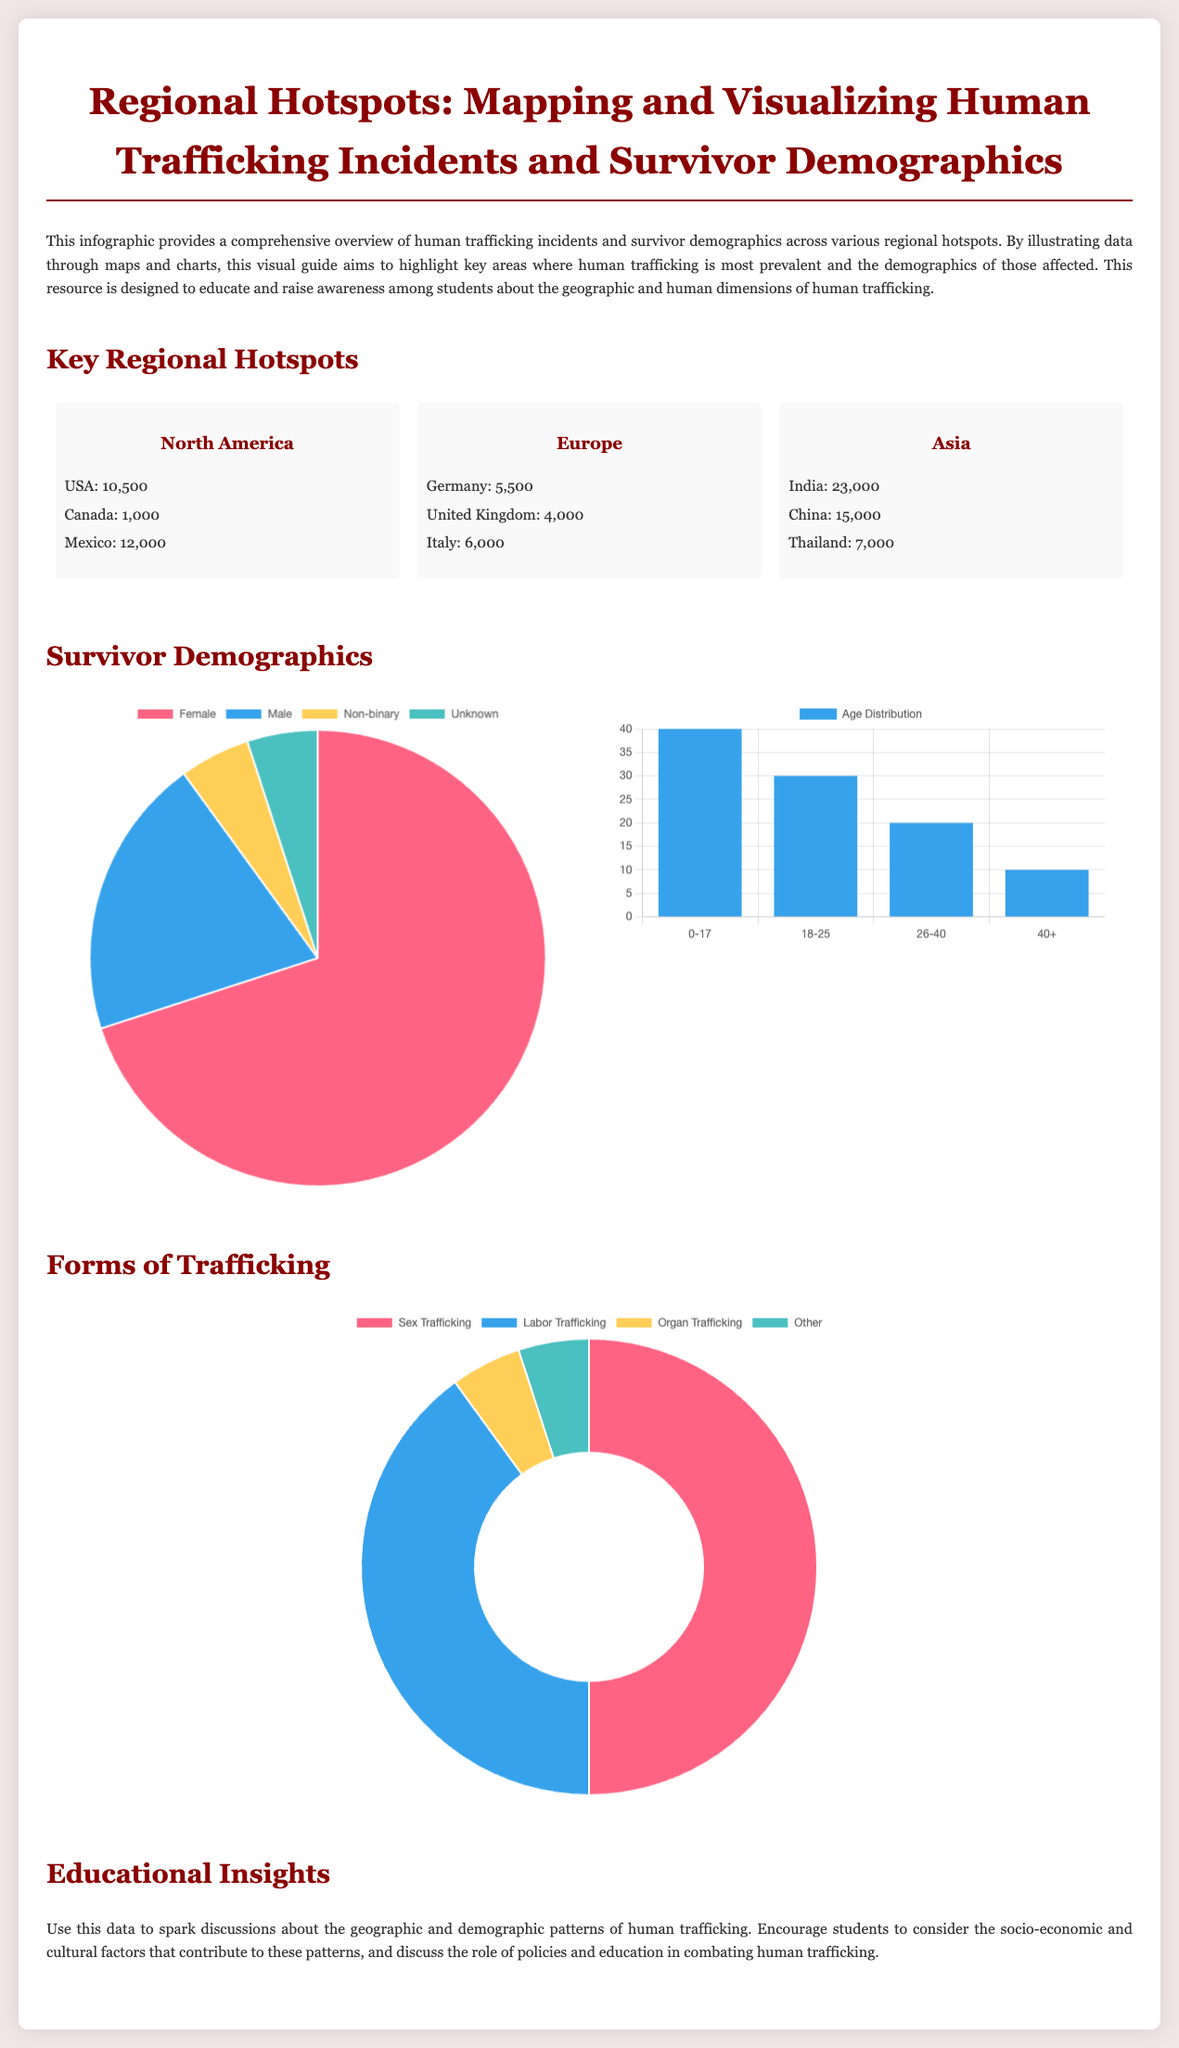what is the total number of human trafficking incidents reported in the USA? The total number of incidents in the USA is specifically mentioned in the North America section of the infographic.
Answer: 10,500 how many human trafficking incidents were reported in Canada? This is a specific retrieval question about the number of incidents mentioned for Canada.
Answer: 1,000 which country in Asia has the highest number of human trafficking incidents? The data shows numbers by country in the Asia section, indicating which one has the highest.
Answer: India what percentage of human trafficking survivors are female? This question refers to the gender distribution chart that shows the percentage of survivors identified as female.
Answer: 70 which age group has the highest number of trafficking survivors? The age distribution chart displays the number of survivors by age group, allowing identification of the highest group.
Answer: 0-17 in which region is sex trafficking the most prevalent type? The types of trafficking chart provides information on the prevalence of different trafficking types in this document.
Answer: 50 how many countries are listed under Europe in the hotspots section? This asks for a specific feature in the map section for Europe, where a count of countries is provided.
Answer: 3 what is the total number of trafficking incidents in North America? This requires reasoning by summing the incidents in USA, Canada, and Mexico mentioned in the overview.
Answer: 23,500 what visual representation is used to show age distribution? The age distribution segment specifies the type of chart used to illustrate the data visually.
Answer: Bar chart 